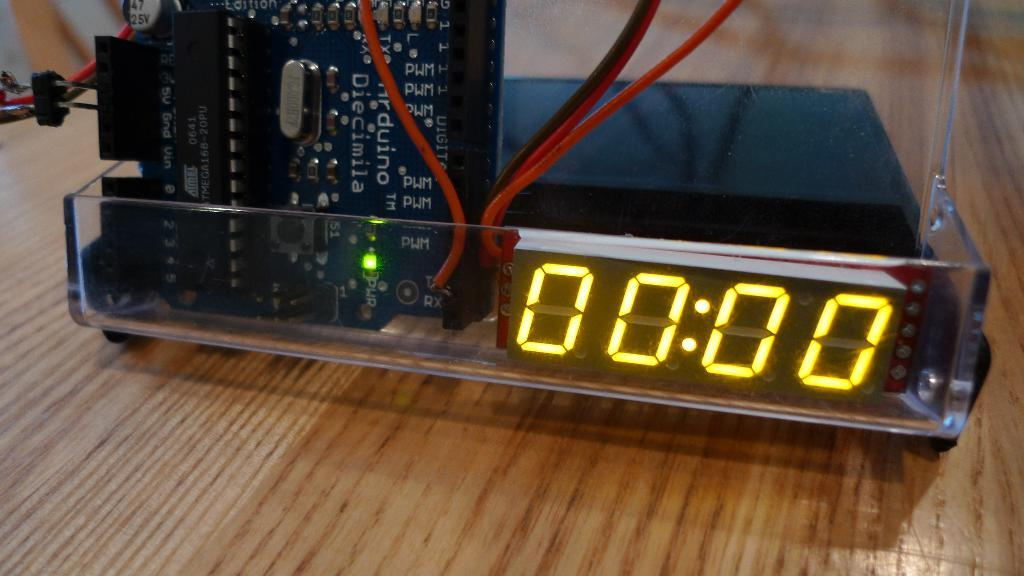<image>
Write a terse but informative summary of the picture. A makeshift clock reading 00:00 in a clear plastic case 